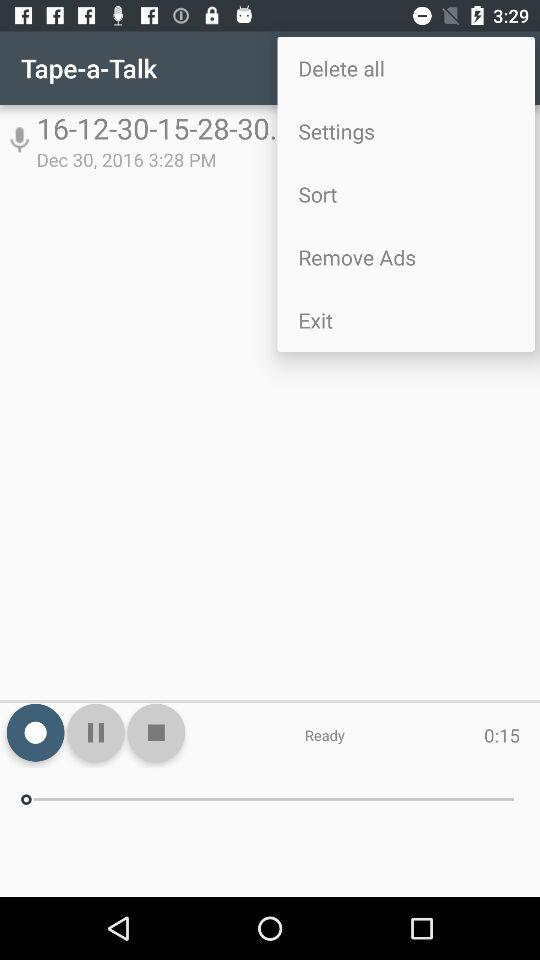What is the date? The date is December 30, 2016. 